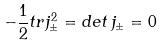Convert formula to latex. <formula><loc_0><loc_0><loc_500><loc_500>- \frac { 1 } { 2 } t r j ^ { 2 } _ { \pm } = d e t \, j _ { \pm } = 0</formula> 